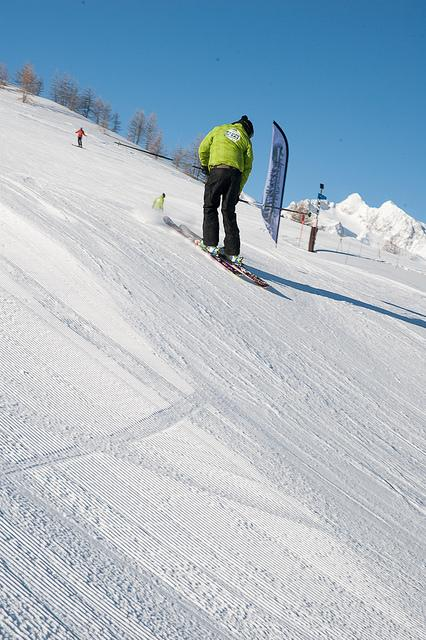What is this sport name?

Choices:
A) swimming
B) skiing
C) sky diving
D) skating skiing 